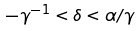Convert formula to latex. <formula><loc_0><loc_0><loc_500><loc_500>- \gamma ^ { - 1 } < \delta < \alpha / \gamma</formula> 